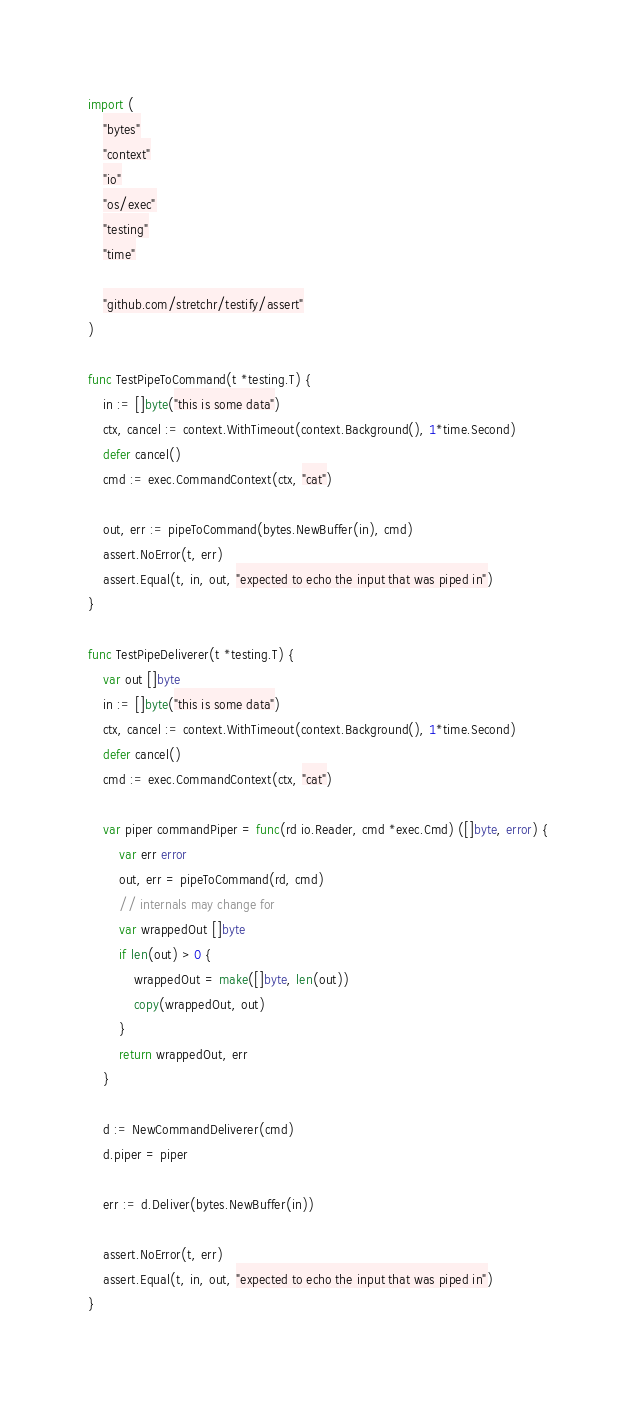<code> <loc_0><loc_0><loc_500><loc_500><_Go_>import (
	"bytes"
	"context"
	"io"
	"os/exec"
	"testing"
	"time"

	"github.com/stretchr/testify/assert"
)

func TestPipeToCommand(t *testing.T) {
	in := []byte("this is some data")
	ctx, cancel := context.WithTimeout(context.Background(), 1*time.Second)
	defer cancel()
	cmd := exec.CommandContext(ctx, "cat")

	out, err := pipeToCommand(bytes.NewBuffer(in), cmd)
	assert.NoError(t, err)
	assert.Equal(t, in, out, "expected to echo the input that was piped in")
}

func TestPipeDeliverer(t *testing.T) {
	var out []byte
	in := []byte("this is some data")
	ctx, cancel := context.WithTimeout(context.Background(), 1*time.Second)
	defer cancel()
	cmd := exec.CommandContext(ctx, "cat")

	var piper commandPiper = func(rd io.Reader, cmd *exec.Cmd) ([]byte, error) {
		var err error
		out, err = pipeToCommand(rd, cmd)
		// internals may change for
		var wrappedOut []byte
		if len(out) > 0 {
			wrappedOut = make([]byte, len(out))
			copy(wrappedOut, out)
		}
		return wrappedOut, err
	}

	d := NewCommandDeliverer(cmd)
	d.piper = piper

	err := d.Deliver(bytes.NewBuffer(in))

	assert.NoError(t, err)
	assert.Equal(t, in, out, "expected to echo the input that was piped in")
}
</code> 